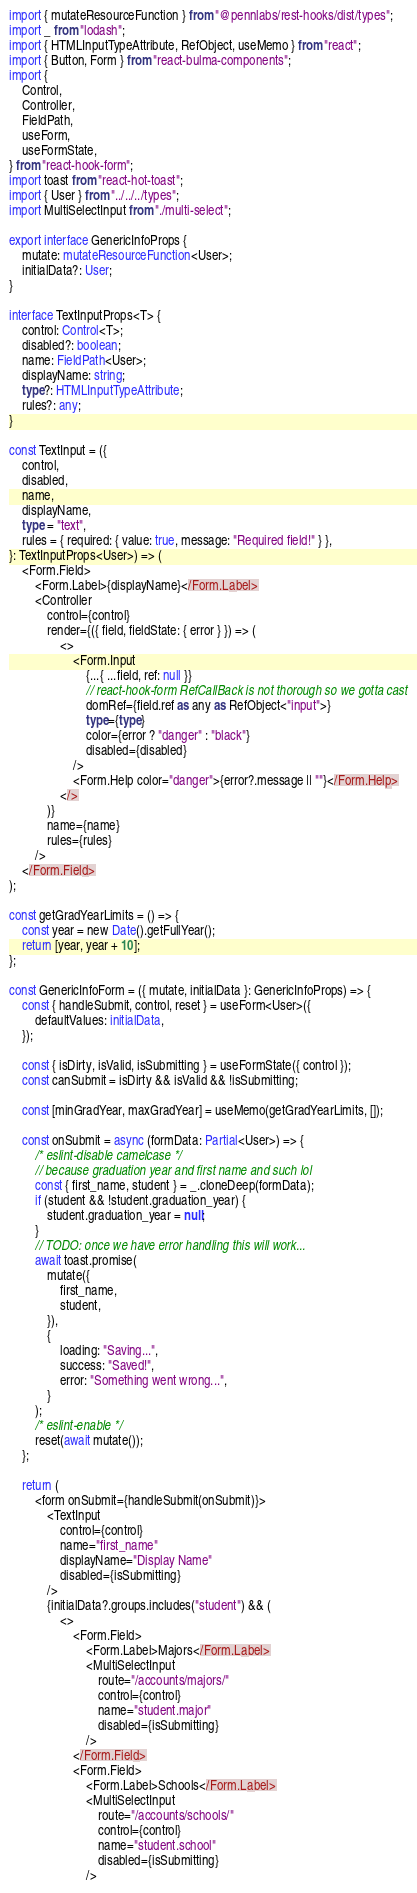Convert code to text. <code><loc_0><loc_0><loc_500><loc_500><_TypeScript_>import { mutateResourceFunction } from "@pennlabs/rest-hooks/dist/types";
import _ from "lodash";
import { HTMLInputTypeAttribute, RefObject, useMemo } from "react";
import { Button, Form } from "react-bulma-components";
import {
    Control,
    Controller,
    FieldPath,
    useForm,
    useFormState,
} from "react-hook-form";
import toast from "react-hot-toast";
import { User } from "../../../types";
import MultiSelectInput from "./multi-select";

export interface GenericInfoProps {
    mutate: mutateResourceFunction<User>;
    initialData?: User;
}

interface TextInputProps<T> {
    control: Control<T>;
    disabled?: boolean;
    name: FieldPath<User>;
    displayName: string;
    type?: HTMLInputTypeAttribute;
    rules?: any;
}

const TextInput = ({
    control,
    disabled,
    name,
    displayName,
    type = "text",
    rules = { required: { value: true, message: "Required field!" } },
}: TextInputProps<User>) => (
    <Form.Field>
        <Form.Label>{displayName}</Form.Label>
        <Controller
            control={control}
            render={({ field, fieldState: { error } }) => (
                <>
                    <Form.Input
                        {...{ ...field, ref: null }}
                        // react-hook-form RefCallBack is not thorough so we gotta cast
                        domRef={field.ref as any as RefObject<"input">}
                        type={type}
                        color={error ? "danger" : "black"}
                        disabled={disabled}
                    />
                    <Form.Help color="danger">{error?.message || ""}</Form.Help>
                </>
            )}
            name={name}
            rules={rules}
        />
    </Form.Field>
);

const getGradYearLimits = () => {
    const year = new Date().getFullYear();
    return [year, year + 10];
};

const GenericInfoForm = ({ mutate, initialData }: GenericInfoProps) => {
    const { handleSubmit, control, reset } = useForm<User>({
        defaultValues: initialData,
    });

    const { isDirty, isValid, isSubmitting } = useFormState({ control });
    const canSubmit = isDirty && isValid && !isSubmitting;

    const [minGradYear, maxGradYear] = useMemo(getGradYearLimits, []);

    const onSubmit = async (formData: Partial<User>) => {
        /* eslint-disable camelcase */
        // because graduation year and first name and such lol
        const { first_name, student } = _.cloneDeep(formData);
        if (student && !student.graduation_year) {
            student.graduation_year = null;
        }
        // TODO: once we have error handling this will work...
        await toast.promise(
            mutate({
                first_name,
                student,
            }),
            {
                loading: "Saving...",
                success: "Saved!",
                error: "Something went wrong...",
            }
        );
        /* eslint-enable */
        reset(await mutate());
    };

    return (
        <form onSubmit={handleSubmit(onSubmit)}>
            <TextInput
                control={control}
                name="first_name"
                displayName="Display Name"
                disabled={isSubmitting}
            />
            {initialData?.groups.includes("student") && (
                <>
                    <Form.Field>
                        <Form.Label>Majors</Form.Label>
                        <MultiSelectInput
                            route="/accounts/majors/"
                            control={control}
                            name="student.major"
                            disabled={isSubmitting}
                        />
                    </Form.Field>
                    <Form.Field>
                        <Form.Label>Schools</Form.Label>
                        <MultiSelectInput
                            route="/accounts/schools/"
                            control={control}
                            name="student.school"
                            disabled={isSubmitting}
                        /></code> 